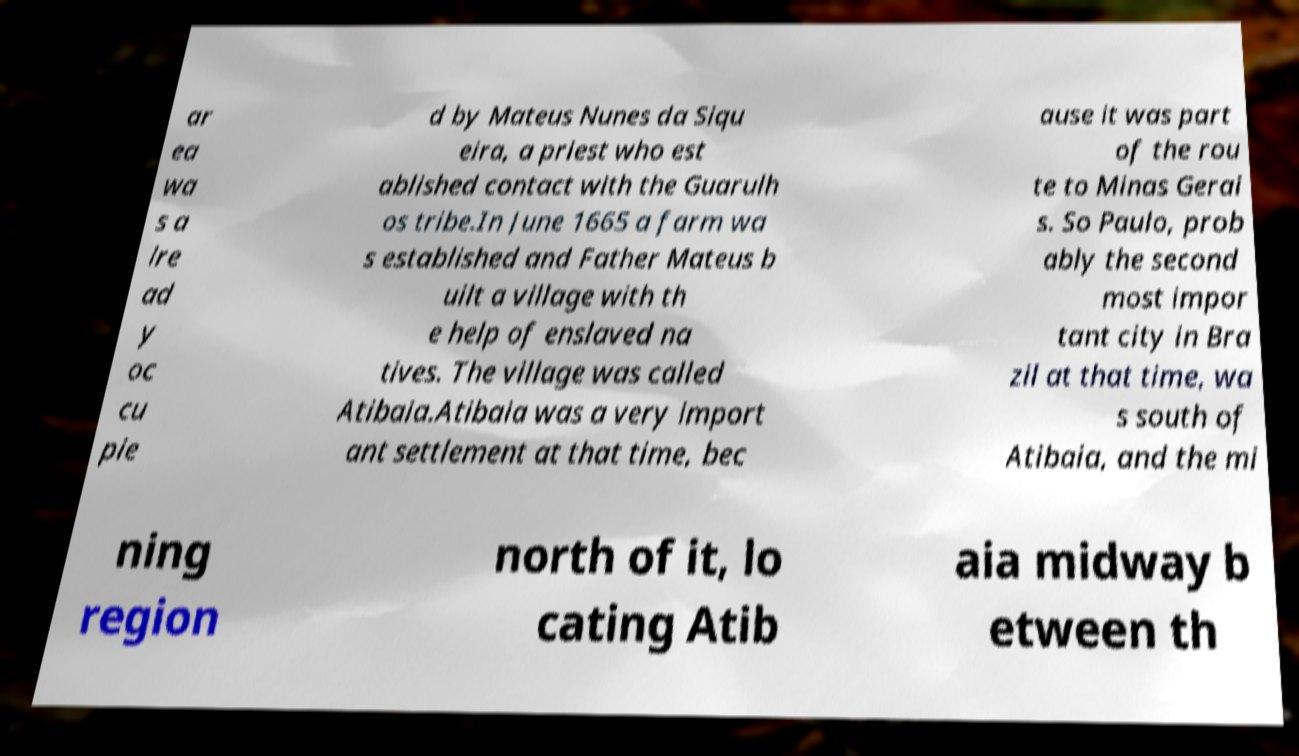There's text embedded in this image that I need extracted. Can you transcribe it verbatim? ar ea wa s a lre ad y oc cu pie d by Mateus Nunes da Siqu eira, a priest who est ablished contact with the Guarulh os tribe.In June 1665 a farm wa s established and Father Mateus b uilt a village with th e help of enslaved na tives. The village was called Atibaia.Atibaia was a very import ant settlement at that time, bec ause it was part of the rou te to Minas Gerai s. So Paulo, prob ably the second most impor tant city in Bra zil at that time, wa s south of Atibaia, and the mi ning region north of it, lo cating Atib aia midway b etween th 